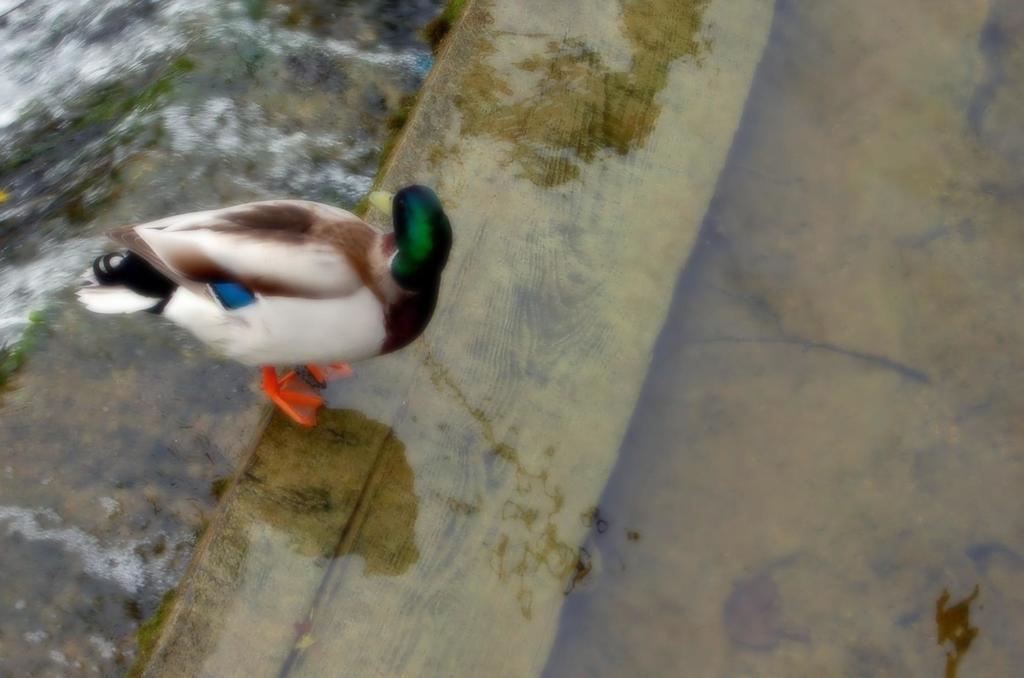Describe this image in one or two sentences. Here I can see a white color bird is standing on the ground where I can see some water. 